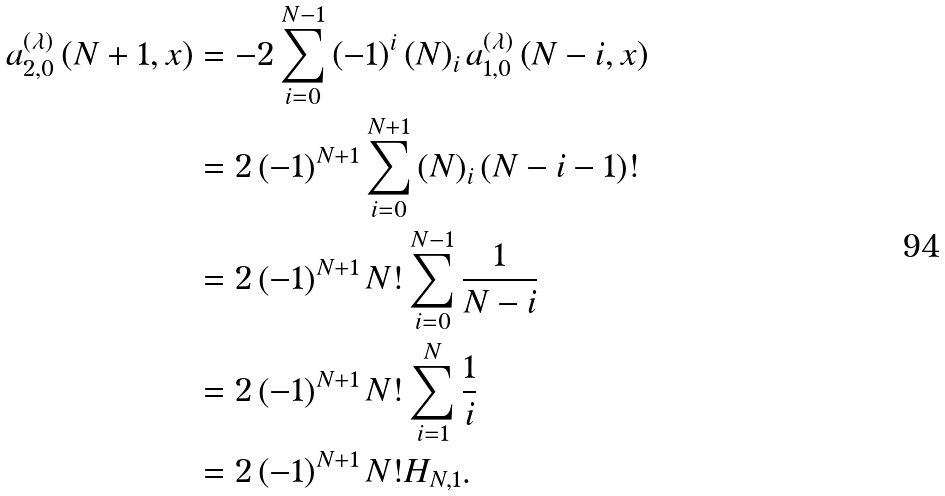Convert formula to latex. <formula><loc_0><loc_0><loc_500><loc_500>a _ { 2 , 0 } ^ { \left ( \lambda \right ) } \left ( N + 1 , x \right ) & = - 2 \sum _ { i = 0 } ^ { N - 1 } \left ( - 1 \right ) ^ { i } \left ( N \right ) _ { i } a _ { 1 , 0 } ^ { \left ( \lambda \right ) } \left ( N - i , x \right ) \\ & = 2 \left ( - 1 \right ) ^ { N + 1 } \sum _ { i = 0 } ^ { N + 1 } \left ( N \right ) _ { i } \left ( N - i - 1 \right ) ! \\ & = 2 \left ( - 1 \right ) ^ { N + 1 } N ! \sum _ { i = 0 } ^ { N - 1 } \frac { 1 } { N - i } \\ & = 2 \left ( - 1 \right ) ^ { N + 1 } N ! \sum _ { i = 1 } ^ { N } \frac { 1 } { i } \\ & = 2 \left ( - 1 \right ) ^ { N + 1 } N ! H _ { N , 1 } .</formula> 